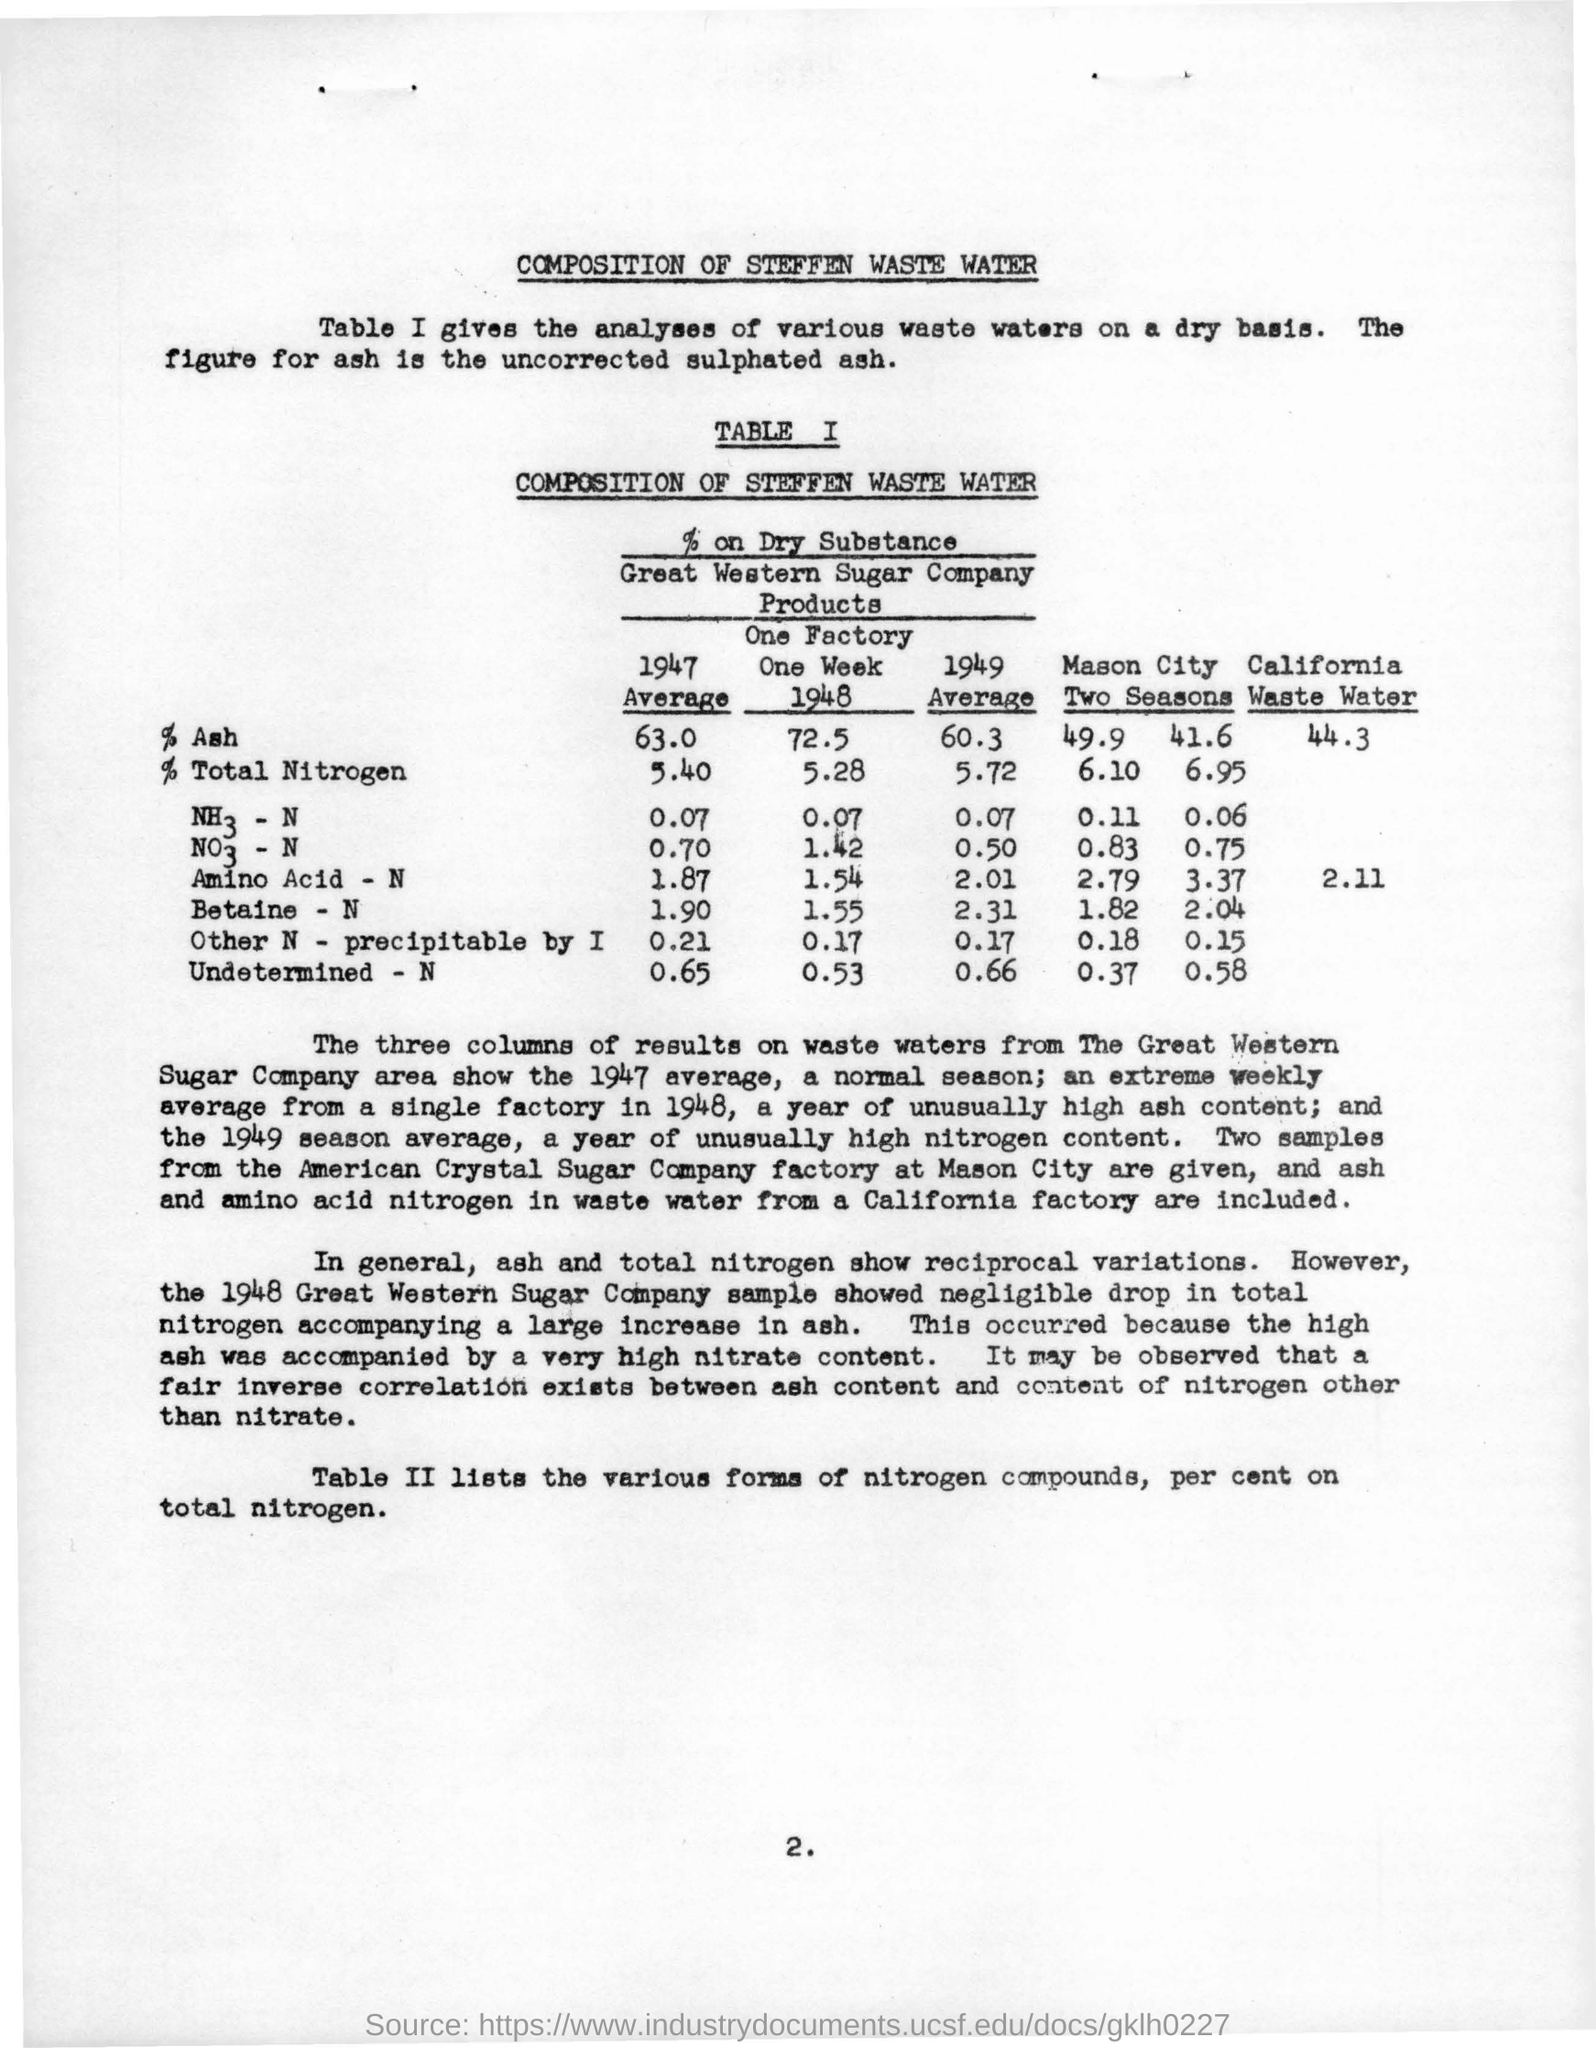Draw attention to some important aspects in this diagram. In 1947, the average percentage of total nitrogen was calculated to be 5.40%. The title of the table provided is "Composition of Steffen Waste Water. I'm sorry, but I'm not sure what you are asking. Could you please provide more context or clarify your question? The name of the company is Great Western Sugar Company. In 1949, the average value of the percentage of ash in a sample was 60.3%. 